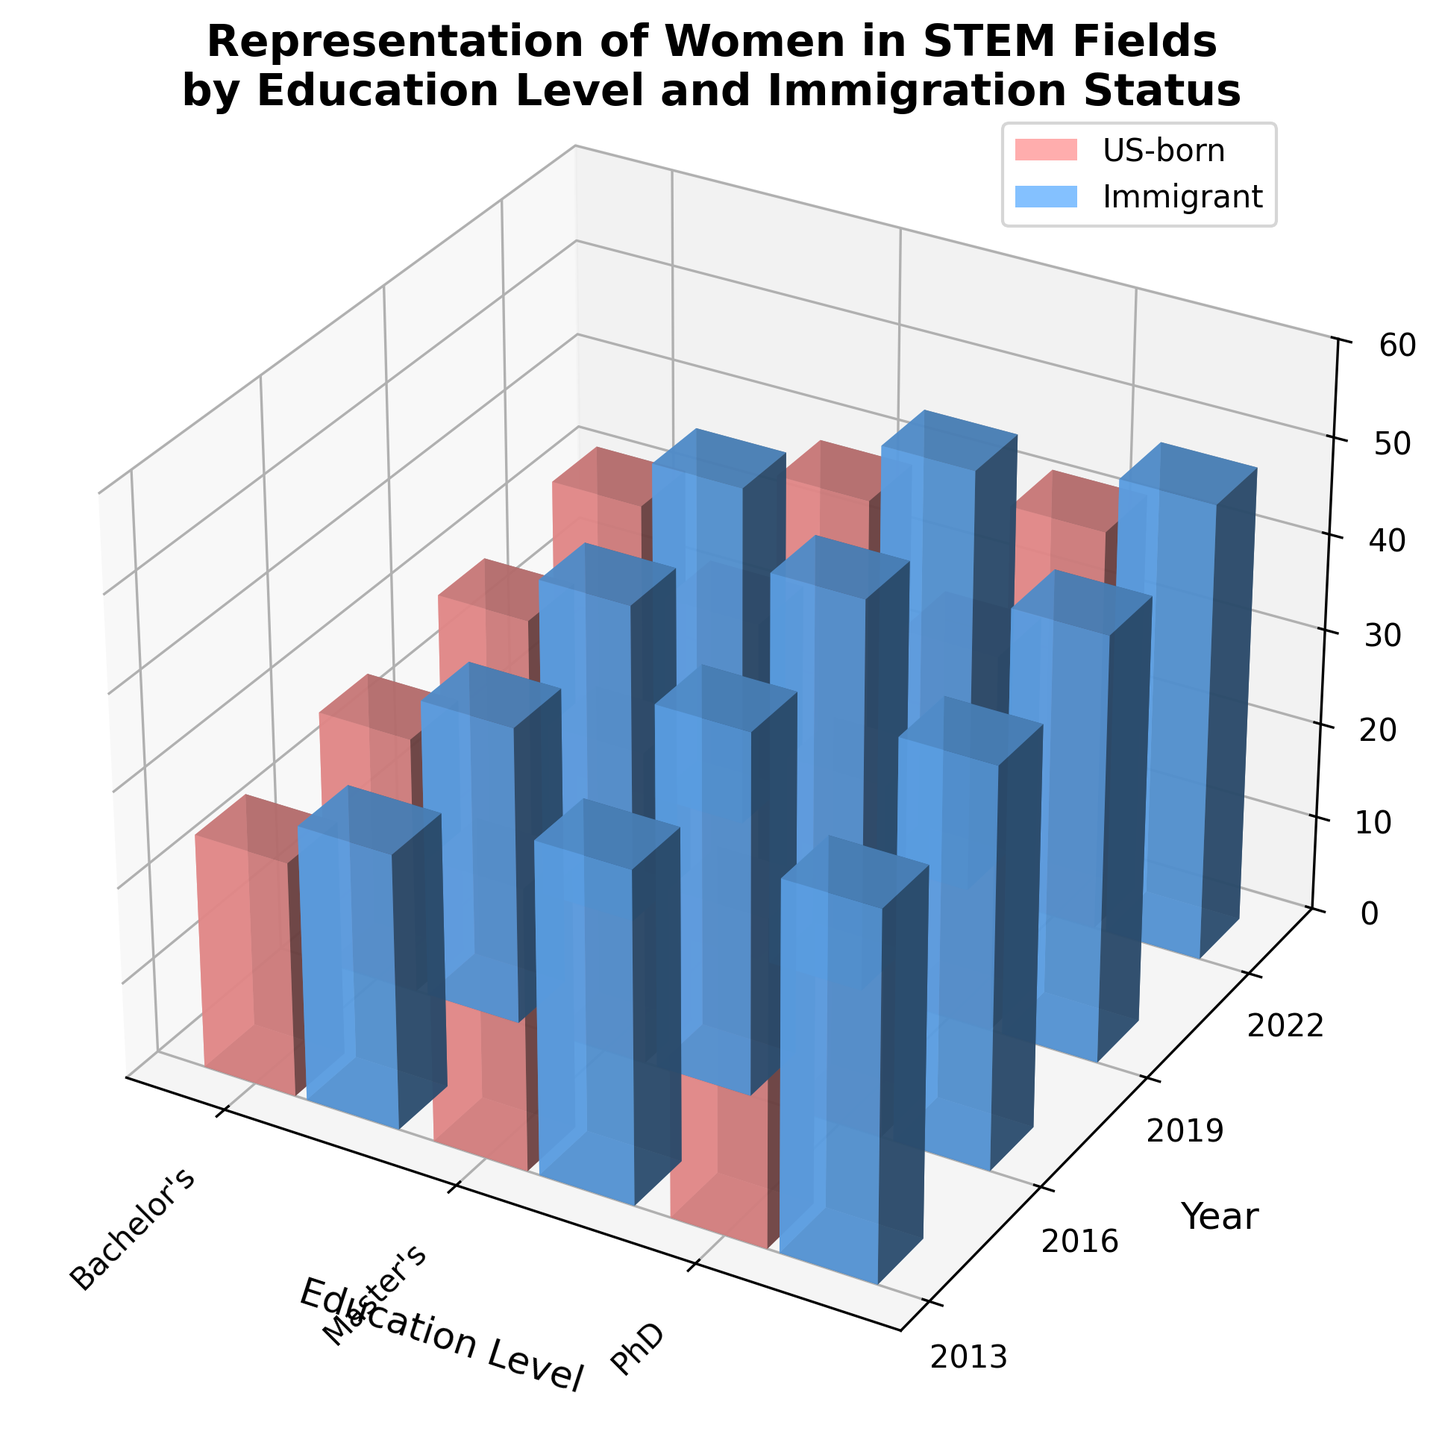what are the two possible immigration statuses represented in the plot? The immigration statuses are represented by two colors in the plot. By examining the legend in the upper left corner, we see the colors correspond to "US-born" and "Immigrant" statuses.
Answer: US-born, Immigrant Which education level showed the highest percentage of women in STEM fields for immigrants in 2022? To find the highest percentage for immigrants in 2022, check the heights of the bars related to immigrant women in 2022, then identify the tallest one, which corresponds to "PhD" at 47.9%.
Answer: PhD How did the percentage of US-born women with Bachelor's degrees in STEM change from 2013 to 2016? Locate the bars for US-born with Bachelor's degrees in 2013 and 2016, then compare their heights. The percentage increases from 24.5% in 2013 to 26.8% in 2016.
Answer: Increased by 2.3% Compare the percentage of immigrant women with Master's degrees in STEM fields in 2016 and 2019. Which year had the higher percentage? Check the bars for immigrant women with Master's degrees in 2016 and 2019. The 2016 bar shows 37.9%, while the 2019 bar shows 41.3%, making 2019 higher.
Answer: 2019 Which group and year had the lowest representation of women in STEM fields? Look for the shortest bar across all categories and years. The shortest bar is for US-born women with Bachelor's degrees in 2013 at 24.5%.
Answer: US-born, Bachelor's, 2013 Has the percentage of US-born women with PhDs in STEM fields been increasing or decreasing over the years? Inspect the bars for US-born women with PhDs across different years. The heights show an upward trend from 33.8% in 2013 to 42.1% in 2022.
Answer: Increasing What's the difference in the percentage of immigrant women with Bachelor's degrees in STEM fields between 2016 and 2022? Subtract the percentage in 2016 (31.2%) from the percentage in 2022 (36.4%) for immigrant women with Bachelor's degrees in 36.4% - 31.2% = 5.2%.
Answer: 5.2% Which education level has seen the most significant increase in the percentage of US-born women in STEM fields from 2013 to 2022? Compare the differences for US-born women in each education level from 2013 to 2022: Bachelor's (31.5%-24.5%), Master's (38.7%-29.3%), PhD (42.1%-33.8%). The highest increase is seen in Bachelor's (7%).
Answer: Bachelor's How does the representation of women in PhD programs (both US-born and Immigrant) change from 2013 to 2019? Examine the bars for PhD in 2013 and 2019. US-born: 33.8% (2013) to 39.2% (2019), Immigrant: 38.2% (2013) to 44.5% (2019). Both groups increased.
Answer: Increased What's the overall pattern of women's representation in STEM fields by immigration status over the decade? Over the decade from 2013 to 2022, both US-born and Immigrant women's representation in STEM fields appears to be increasing, as seen by the growing heights of the bars over the years.
Answer: Increasing 